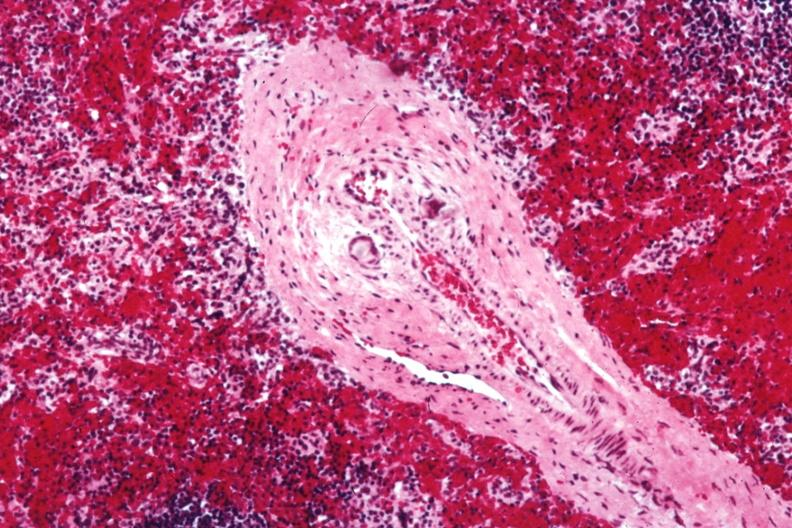s serous cyst present?
Answer the question using a single word or phrase. No 